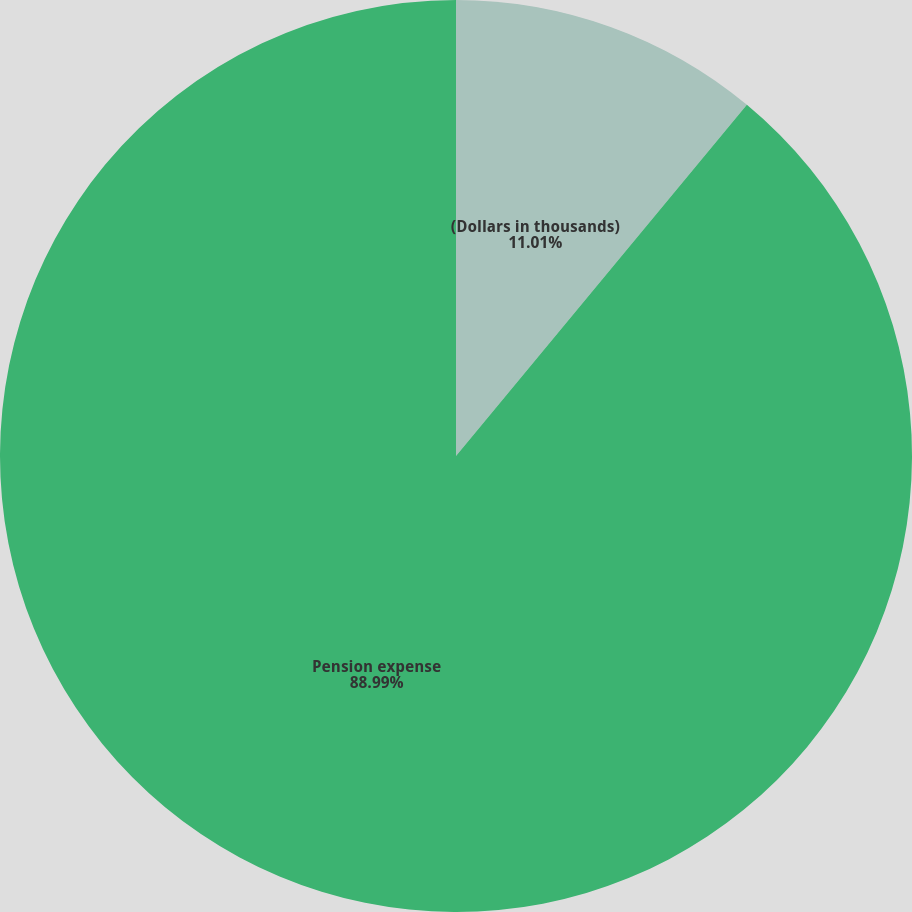Convert chart to OTSL. <chart><loc_0><loc_0><loc_500><loc_500><pie_chart><fcel>(Dollars in thousands)<fcel>Pension expense<nl><fcel>11.01%<fcel>88.99%<nl></chart> 